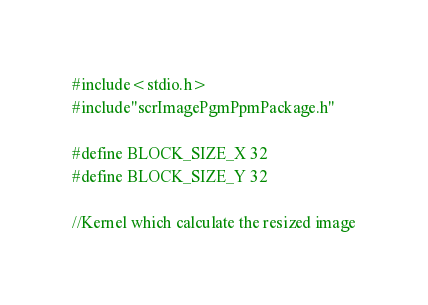Convert code to text. <code><loc_0><loc_0><loc_500><loc_500><_Cuda_>#include<stdio.h>
#include"scrImagePgmPpmPackage.h"

#define BLOCK_SIZE_X 32
#define BLOCK_SIZE_Y 32

//Kernel which calculate the resized image</code> 